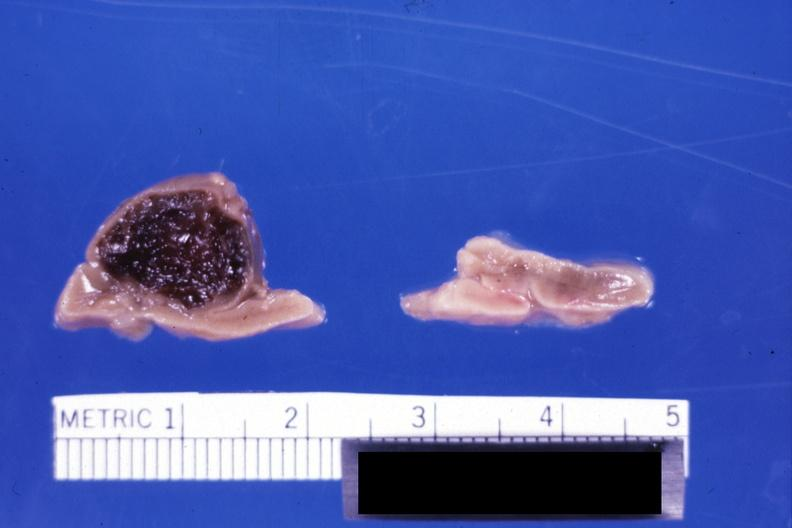what is present?
Answer the question using a single word or phrase. Endocrine 